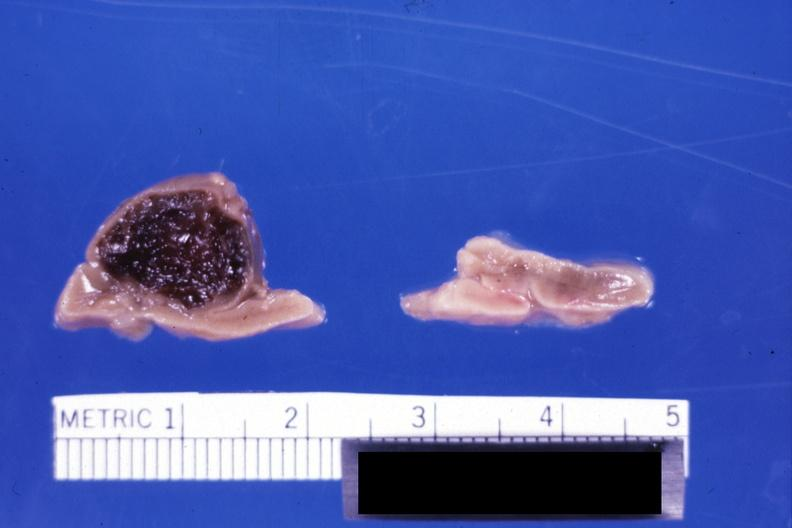what is present?
Answer the question using a single word or phrase. Endocrine 